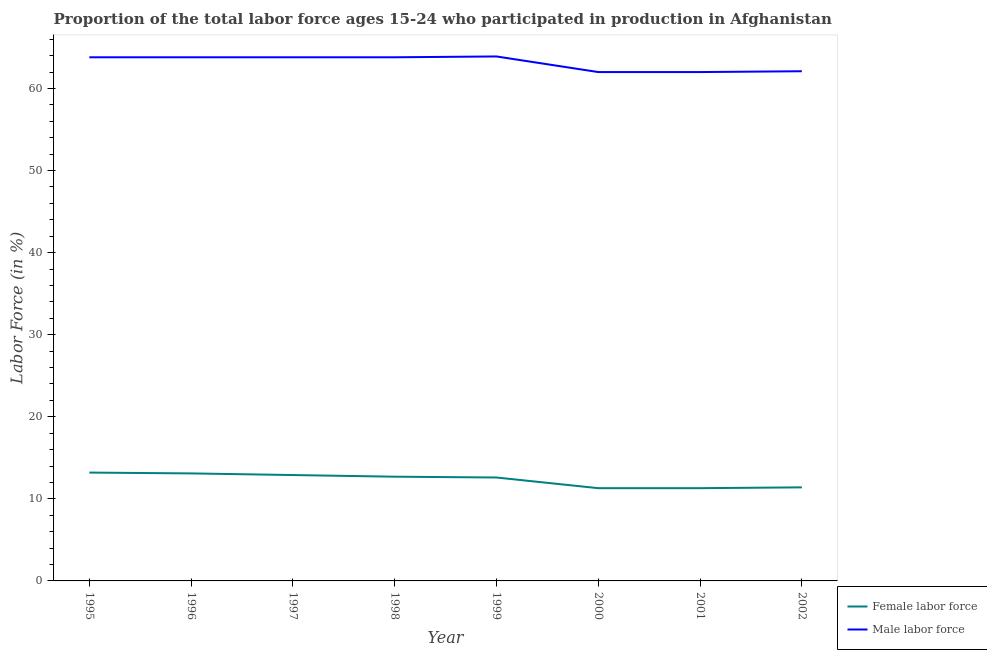How many different coloured lines are there?
Give a very brief answer. 2. Does the line corresponding to percentage of female labor force intersect with the line corresponding to percentage of male labour force?
Make the answer very short. No. Is the number of lines equal to the number of legend labels?
Keep it short and to the point. Yes. What is the percentage of female labor force in 2001?
Ensure brevity in your answer.  11.3. Across all years, what is the maximum percentage of female labor force?
Your response must be concise. 13.2. Across all years, what is the minimum percentage of female labor force?
Ensure brevity in your answer.  11.3. What is the total percentage of female labor force in the graph?
Offer a very short reply. 98.5. What is the difference between the percentage of male labour force in 1999 and that in 2001?
Provide a succinct answer. 1.9. What is the difference between the percentage of male labour force in 1997 and the percentage of female labor force in 1995?
Offer a very short reply. 50.6. What is the average percentage of female labor force per year?
Provide a short and direct response. 12.31. In the year 1999, what is the difference between the percentage of male labour force and percentage of female labor force?
Your answer should be compact. 51.3. What is the ratio of the percentage of female labor force in 1996 to that in 2002?
Keep it short and to the point. 1.15. What is the difference between the highest and the second highest percentage of male labour force?
Your answer should be very brief. 0.1. What is the difference between the highest and the lowest percentage of female labor force?
Your answer should be very brief. 1.9. In how many years, is the percentage of female labor force greater than the average percentage of female labor force taken over all years?
Offer a very short reply. 5. Is the sum of the percentage of male labour force in 1998 and 2002 greater than the maximum percentage of female labor force across all years?
Make the answer very short. Yes. Is the percentage of male labour force strictly greater than the percentage of female labor force over the years?
Provide a short and direct response. Yes. What is the difference between two consecutive major ticks on the Y-axis?
Provide a short and direct response. 10. Are the values on the major ticks of Y-axis written in scientific E-notation?
Make the answer very short. No. Does the graph contain any zero values?
Ensure brevity in your answer.  No. Does the graph contain grids?
Ensure brevity in your answer.  No. Where does the legend appear in the graph?
Provide a succinct answer. Bottom right. What is the title of the graph?
Make the answer very short. Proportion of the total labor force ages 15-24 who participated in production in Afghanistan. Does "Current US$" appear as one of the legend labels in the graph?
Offer a terse response. No. What is the label or title of the Y-axis?
Keep it short and to the point. Labor Force (in %). What is the Labor Force (in %) of Female labor force in 1995?
Give a very brief answer. 13.2. What is the Labor Force (in %) of Male labor force in 1995?
Offer a very short reply. 63.8. What is the Labor Force (in %) in Female labor force in 1996?
Your answer should be compact. 13.1. What is the Labor Force (in %) in Male labor force in 1996?
Your answer should be compact. 63.8. What is the Labor Force (in %) in Female labor force in 1997?
Make the answer very short. 12.9. What is the Labor Force (in %) in Male labor force in 1997?
Your answer should be very brief. 63.8. What is the Labor Force (in %) in Female labor force in 1998?
Provide a short and direct response. 12.7. What is the Labor Force (in %) of Male labor force in 1998?
Offer a very short reply. 63.8. What is the Labor Force (in %) in Female labor force in 1999?
Offer a terse response. 12.6. What is the Labor Force (in %) of Male labor force in 1999?
Ensure brevity in your answer.  63.9. What is the Labor Force (in %) in Female labor force in 2000?
Provide a short and direct response. 11.3. What is the Labor Force (in %) of Female labor force in 2001?
Give a very brief answer. 11.3. What is the Labor Force (in %) of Male labor force in 2001?
Offer a very short reply. 62. What is the Labor Force (in %) in Female labor force in 2002?
Your response must be concise. 11.4. What is the Labor Force (in %) in Male labor force in 2002?
Offer a very short reply. 62.1. Across all years, what is the maximum Labor Force (in %) of Female labor force?
Ensure brevity in your answer.  13.2. Across all years, what is the maximum Labor Force (in %) in Male labor force?
Make the answer very short. 63.9. Across all years, what is the minimum Labor Force (in %) in Female labor force?
Ensure brevity in your answer.  11.3. Across all years, what is the minimum Labor Force (in %) in Male labor force?
Make the answer very short. 62. What is the total Labor Force (in %) in Female labor force in the graph?
Give a very brief answer. 98.5. What is the total Labor Force (in %) in Male labor force in the graph?
Give a very brief answer. 505.2. What is the difference between the Labor Force (in %) in Female labor force in 1995 and that in 1996?
Provide a short and direct response. 0.1. What is the difference between the Labor Force (in %) of Female labor force in 1995 and that in 1998?
Your response must be concise. 0.5. What is the difference between the Labor Force (in %) of Female labor force in 1995 and that in 1999?
Your answer should be very brief. 0.6. What is the difference between the Labor Force (in %) of Male labor force in 1995 and that in 1999?
Offer a terse response. -0.1. What is the difference between the Labor Force (in %) of Female labor force in 1995 and that in 2000?
Your answer should be very brief. 1.9. What is the difference between the Labor Force (in %) in Male labor force in 1995 and that in 2000?
Ensure brevity in your answer.  1.8. What is the difference between the Labor Force (in %) of Female labor force in 1995 and that in 2001?
Your answer should be compact. 1.9. What is the difference between the Labor Force (in %) of Female labor force in 1995 and that in 2002?
Provide a succinct answer. 1.8. What is the difference between the Labor Force (in %) of Male labor force in 1995 and that in 2002?
Give a very brief answer. 1.7. What is the difference between the Labor Force (in %) of Female labor force in 1996 and that in 1997?
Offer a very short reply. 0.2. What is the difference between the Labor Force (in %) of Male labor force in 1996 and that in 1998?
Your answer should be compact. 0. What is the difference between the Labor Force (in %) of Female labor force in 1996 and that in 1999?
Offer a terse response. 0.5. What is the difference between the Labor Force (in %) in Male labor force in 1996 and that in 1999?
Ensure brevity in your answer.  -0.1. What is the difference between the Labor Force (in %) in Female labor force in 1996 and that in 2000?
Ensure brevity in your answer.  1.8. What is the difference between the Labor Force (in %) in Male labor force in 1996 and that in 2001?
Make the answer very short. 1.8. What is the difference between the Labor Force (in %) in Male labor force in 1996 and that in 2002?
Your response must be concise. 1.7. What is the difference between the Labor Force (in %) in Female labor force in 1997 and that in 1998?
Ensure brevity in your answer.  0.2. What is the difference between the Labor Force (in %) of Male labor force in 1997 and that in 1999?
Provide a succinct answer. -0.1. What is the difference between the Labor Force (in %) in Female labor force in 1997 and that in 2000?
Your response must be concise. 1.6. What is the difference between the Labor Force (in %) of Female labor force in 1997 and that in 2002?
Your response must be concise. 1.5. What is the difference between the Labor Force (in %) in Male labor force in 1997 and that in 2002?
Provide a short and direct response. 1.7. What is the difference between the Labor Force (in %) of Female labor force in 1998 and that in 1999?
Offer a terse response. 0.1. What is the difference between the Labor Force (in %) in Male labor force in 1998 and that in 1999?
Keep it short and to the point. -0.1. What is the difference between the Labor Force (in %) in Female labor force in 1998 and that in 2000?
Offer a very short reply. 1.4. What is the difference between the Labor Force (in %) in Female labor force in 1998 and that in 2002?
Your answer should be compact. 1.3. What is the difference between the Labor Force (in %) of Male labor force in 1998 and that in 2002?
Your answer should be very brief. 1.7. What is the difference between the Labor Force (in %) in Female labor force in 1999 and that in 2000?
Ensure brevity in your answer.  1.3. What is the difference between the Labor Force (in %) of Female labor force in 1999 and that in 2001?
Make the answer very short. 1.3. What is the difference between the Labor Force (in %) of Male labor force in 1999 and that in 2001?
Provide a short and direct response. 1.9. What is the difference between the Labor Force (in %) of Female labor force in 1999 and that in 2002?
Your answer should be compact. 1.2. What is the difference between the Labor Force (in %) in Male labor force in 1999 and that in 2002?
Give a very brief answer. 1.8. What is the difference between the Labor Force (in %) in Female labor force in 2000 and that in 2001?
Offer a terse response. 0. What is the difference between the Labor Force (in %) in Male labor force in 2000 and that in 2001?
Make the answer very short. 0. What is the difference between the Labor Force (in %) in Male labor force in 2000 and that in 2002?
Your answer should be compact. -0.1. What is the difference between the Labor Force (in %) in Female labor force in 2001 and that in 2002?
Your answer should be very brief. -0.1. What is the difference between the Labor Force (in %) in Male labor force in 2001 and that in 2002?
Your answer should be compact. -0.1. What is the difference between the Labor Force (in %) of Female labor force in 1995 and the Labor Force (in %) of Male labor force in 1996?
Offer a very short reply. -50.6. What is the difference between the Labor Force (in %) in Female labor force in 1995 and the Labor Force (in %) in Male labor force in 1997?
Ensure brevity in your answer.  -50.6. What is the difference between the Labor Force (in %) in Female labor force in 1995 and the Labor Force (in %) in Male labor force in 1998?
Your answer should be very brief. -50.6. What is the difference between the Labor Force (in %) of Female labor force in 1995 and the Labor Force (in %) of Male labor force in 1999?
Your answer should be very brief. -50.7. What is the difference between the Labor Force (in %) of Female labor force in 1995 and the Labor Force (in %) of Male labor force in 2000?
Provide a short and direct response. -48.8. What is the difference between the Labor Force (in %) of Female labor force in 1995 and the Labor Force (in %) of Male labor force in 2001?
Provide a succinct answer. -48.8. What is the difference between the Labor Force (in %) of Female labor force in 1995 and the Labor Force (in %) of Male labor force in 2002?
Keep it short and to the point. -48.9. What is the difference between the Labor Force (in %) of Female labor force in 1996 and the Labor Force (in %) of Male labor force in 1997?
Provide a short and direct response. -50.7. What is the difference between the Labor Force (in %) in Female labor force in 1996 and the Labor Force (in %) in Male labor force in 1998?
Provide a succinct answer. -50.7. What is the difference between the Labor Force (in %) of Female labor force in 1996 and the Labor Force (in %) of Male labor force in 1999?
Give a very brief answer. -50.8. What is the difference between the Labor Force (in %) of Female labor force in 1996 and the Labor Force (in %) of Male labor force in 2000?
Make the answer very short. -48.9. What is the difference between the Labor Force (in %) in Female labor force in 1996 and the Labor Force (in %) in Male labor force in 2001?
Your response must be concise. -48.9. What is the difference between the Labor Force (in %) in Female labor force in 1996 and the Labor Force (in %) in Male labor force in 2002?
Give a very brief answer. -49. What is the difference between the Labor Force (in %) in Female labor force in 1997 and the Labor Force (in %) in Male labor force in 1998?
Your answer should be compact. -50.9. What is the difference between the Labor Force (in %) in Female labor force in 1997 and the Labor Force (in %) in Male labor force in 1999?
Keep it short and to the point. -51. What is the difference between the Labor Force (in %) of Female labor force in 1997 and the Labor Force (in %) of Male labor force in 2000?
Provide a short and direct response. -49.1. What is the difference between the Labor Force (in %) in Female labor force in 1997 and the Labor Force (in %) in Male labor force in 2001?
Offer a terse response. -49.1. What is the difference between the Labor Force (in %) in Female labor force in 1997 and the Labor Force (in %) in Male labor force in 2002?
Your response must be concise. -49.2. What is the difference between the Labor Force (in %) of Female labor force in 1998 and the Labor Force (in %) of Male labor force in 1999?
Provide a succinct answer. -51.2. What is the difference between the Labor Force (in %) of Female labor force in 1998 and the Labor Force (in %) of Male labor force in 2000?
Your response must be concise. -49.3. What is the difference between the Labor Force (in %) in Female labor force in 1998 and the Labor Force (in %) in Male labor force in 2001?
Give a very brief answer. -49.3. What is the difference between the Labor Force (in %) in Female labor force in 1998 and the Labor Force (in %) in Male labor force in 2002?
Your response must be concise. -49.4. What is the difference between the Labor Force (in %) in Female labor force in 1999 and the Labor Force (in %) in Male labor force in 2000?
Ensure brevity in your answer.  -49.4. What is the difference between the Labor Force (in %) of Female labor force in 1999 and the Labor Force (in %) of Male labor force in 2001?
Keep it short and to the point. -49.4. What is the difference between the Labor Force (in %) in Female labor force in 1999 and the Labor Force (in %) in Male labor force in 2002?
Ensure brevity in your answer.  -49.5. What is the difference between the Labor Force (in %) in Female labor force in 2000 and the Labor Force (in %) in Male labor force in 2001?
Make the answer very short. -50.7. What is the difference between the Labor Force (in %) in Female labor force in 2000 and the Labor Force (in %) in Male labor force in 2002?
Your response must be concise. -50.8. What is the difference between the Labor Force (in %) of Female labor force in 2001 and the Labor Force (in %) of Male labor force in 2002?
Offer a very short reply. -50.8. What is the average Labor Force (in %) in Female labor force per year?
Offer a very short reply. 12.31. What is the average Labor Force (in %) in Male labor force per year?
Offer a terse response. 63.15. In the year 1995, what is the difference between the Labor Force (in %) in Female labor force and Labor Force (in %) in Male labor force?
Provide a succinct answer. -50.6. In the year 1996, what is the difference between the Labor Force (in %) of Female labor force and Labor Force (in %) of Male labor force?
Give a very brief answer. -50.7. In the year 1997, what is the difference between the Labor Force (in %) in Female labor force and Labor Force (in %) in Male labor force?
Your response must be concise. -50.9. In the year 1998, what is the difference between the Labor Force (in %) in Female labor force and Labor Force (in %) in Male labor force?
Provide a succinct answer. -51.1. In the year 1999, what is the difference between the Labor Force (in %) of Female labor force and Labor Force (in %) of Male labor force?
Give a very brief answer. -51.3. In the year 2000, what is the difference between the Labor Force (in %) of Female labor force and Labor Force (in %) of Male labor force?
Make the answer very short. -50.7. In the year 2001, what is the difference between the Labor Force (in %) of Female labor force and Labor Force (in %) of Male labor force?
Provide a succinct answer. -50.7. In the year 2002, what is the difference between the Labor Force (in %) in Female labor force and Labor Force (in %) in Male labor force?
Keep it short and to the point. -50.7. What is the ratio of the Labor Force (in %) in Female labor force in 1995 to that in 1996?
Provide a short and direct response. 1.01. What is the ratio of the Labor Force (in %) in Male labor force in 1995 to that in 1996?
Make the answer very short. 1. What is the ratio of the Labor Force (in %) of Female labor force in 1995 to that in 1997?
Ensure brevity in your answer.  1.02. What is the ratio of the Labor Force (in %) of Male labor force in 1995 to that in 1997?
Ensure brevity in your answer.  1. What is the ratio of the Labor Force (in %) in Female labor force in 1995 to that in 1998?
Your answer should be very brief. 1.04. What is the ratio of the Labor Force (in %) of Female labor force in 1995 to that in 1999?
Provide a short and direct response. 1.05. What is the ratio of the Labor Force (in %) of Male labor force in 1995 to that in 1999?
Offer a terse response. 1. What is the ratio of the Labor Force (in %) in Female labor force in 1995 to that in 2000?
Ensure brevity in your answer.  1.17. What is the ratio of the Labor Force (in %) of Female labor force in 1995 to that in 2001?
Your answer should be compact. 1.17. What is the ratio of the Labor Force (in %) of Female labor force in 1995 to that in 2002?
Make the answer very short. 1.16. What is the ratio of the Labor Force (in %) of Male labor force in 1995 to that in 2002?
Your response must be concise. 1.03. What is the ratio of the Labor Force (in %) in Female labor force in 1996 to that in 1997?
Give a very brief answer. 1.02. What is the ratio of the Labor Force (in %) of Male labor force in 1996 to that in 1997?
Your answer should be compact. 1. What is the ratio of the Labor Force (in %) of Female labor force in 1996 to that in 1998?
Offer a very short reply. 1.03. What is the ratio of the Labor Force (in %) of Female labor force in 1996 to that in 1999?
Provide a short and direct response. 1.04. What is the ratio of the Labor Force (in %) of Female labor force in 1996 to that in 2000?
Offer a very short reply. 1.16. What is the ratio of the Labor Force (in %) in Female labor force in 1996 to that in 2001?
Provide a succinct answer. 1.16. What is the ratio of the Labor Force (in %) in Female labor force in 1996 to that in 2002?
Provide a short and direct response. 1.15. What is the ratio of the Labor Force (in %) in Male labor force in 1996 to that in 2002?
Your response must be concise. 1.03. What is the ratio of the Labor Force (in %) in Female labor force in 1997 to that in 1998?
Give a very brief answer. 1.02. What is the ratio of the Labor Force (in %) of Female labor force in 1997 to that in 1999?
Your response must be concise. 1.02. What is the ratio of the Labor Force (in %) of Female labor force in 1997 to that in 2000?
Offer a terse response. 1.14. What is the ratio of the Labor Force (in %) of Female labor force in 1997 to that in 2001?
Provide a succinct answer. 1.14. What is the ratio of the Labor Force (in %) in Male labor force in 1997 to that in 2001?
Offer a very short reply. 1.03. What is the ratio of the Labor Force (in %) of Female labor force in 1997 to that in 2002?
Give a very brief answer. 1.13. What is the ratio of the Labor Force (in %) in Male labor force in 1997 to that in 2002?
Keep it short and to the point. 1.03. What is the ratio of the Labor Force (in %) of Female labor force in 1998 to that in 1999?
Your response must be concise. 1.01. What is the ratio of the Labor Force (in %) of Female labor force in 1998 to that in 2000?
Offer a terse response. 1.12. What is the ratio of the Labor Force (in %) of Male labor force in 1998 to that in 2000?
Keep it short and to the point. 1.03. What is the ratio of the Labor Force (in %) in Female labor force in 1998 to that in 2001?
Give a very brief answer. 1.12. What is the ratio of the Labor Force (in %) of Female labor force in 1998 to that in 2002?
Ensure brevity in your answer.  1.11. What is the ratio of the Labor Force (in %) of Male labor force in 1998 to that in 2002?
Provide a succinct answer. 1.03. What is the ratio of the Labor Force (in %) in Female labor force in 1999 to that in 2000?
Ensure brevity in your answer.  1.11. What is the ratio of the Labor Force (in %) in Male labor force in 1999 to that in 2000?
Give a very brief answer. 1.03. What is the ratio of the Labor Force (in %) of Female labor force in 1999 to that in 2001?
Keep it short and to the point. 1.11. What is the ratio of the Labor Force (in %) of Male labor force in 1999 to that in 2001?
Offer a very short reply. 1.03. What is the ratio of the Labor Force (in %) in Female labor force in 1999 to that in 2002?
Your answer should be compact. 1.11. What is the ratio of the Labor Force (in %) in Female labor force in 2000 to that in 2002?
Provide a short and direct response. 0.99. What is the difference between the highest and the second highest Labor Force (in %) of Female labor force?
Make the answer very short. 0.1. What is the difference between the highest and the second highest Labor Force (in %) of Male labor force?
Offer a terse response. 0.1. What is the difference between the highest and the lowest Labor Force (in %) of Male labor force?
Keep it short and to the point. 1.9. 